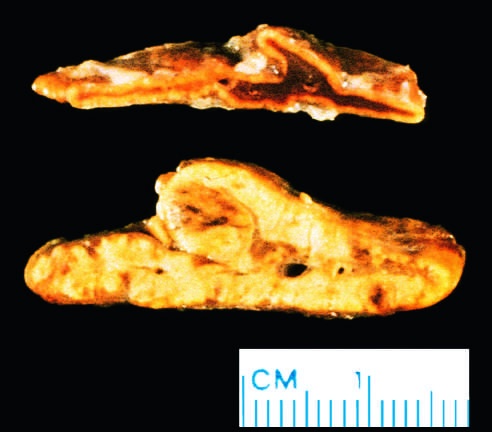was subacute endocarditis from a patient with acth-dependent cushing syndrome, in whom both adrenal glands were diffusely hyperplastic?
Answer the question using a single word or phrase. No 